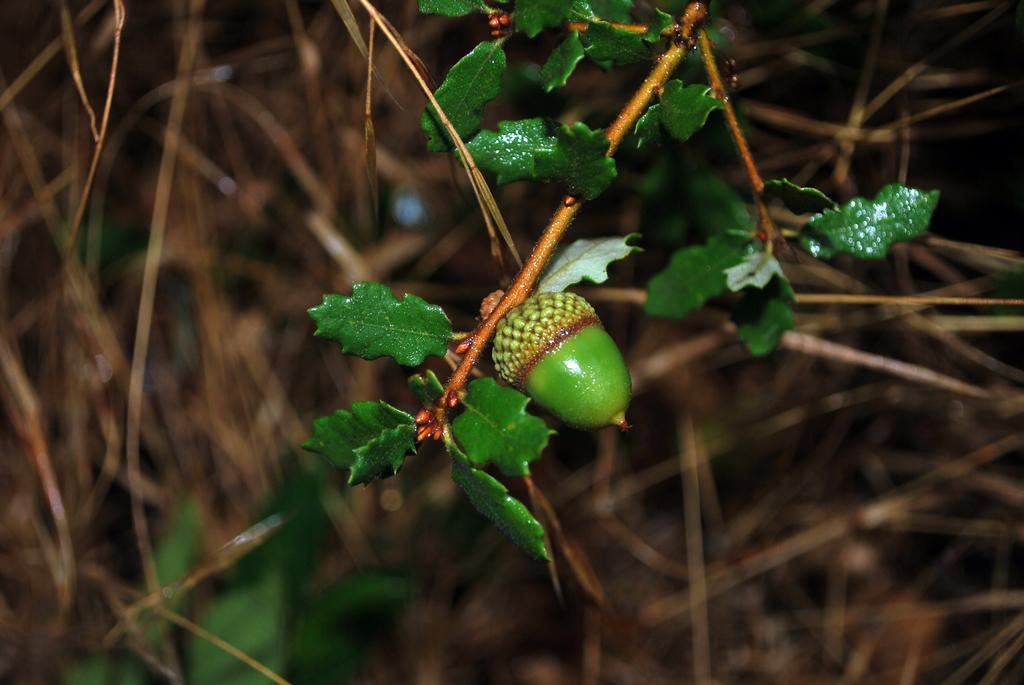What types of living organisms can be seen in the foreground of the image? Plants and fruits are visible in the foreground of the image. Can you describe the vegetation in the foreground? The plants in the foreground include fruits. What can be seen in the background of the image? There is dry grass in the background of the image. Can you see any footprints in the seashore depicted in the image? There is no seashore depicted in the image; it features plants, fruits, and dry grass. Is there any evidence of a battle taking place in the image? There is no indication of a battle or any conflict in the image. 